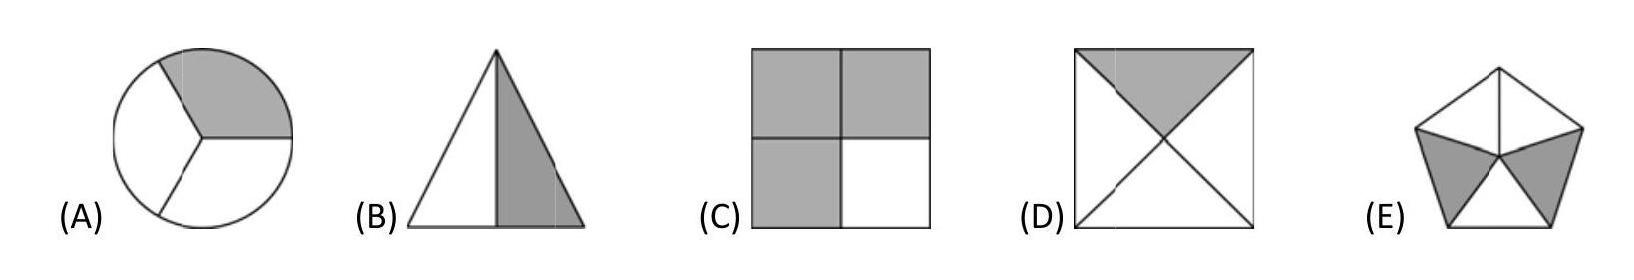Which shape would represent a perfect split if colors were divided horizontally? If we divided the shapes horizontally, shape D would depict a perfect split. The square is divided by diagonal lines into four triangles of equal size, with opposing triangles colored grey. A horizontal division would evenly split these triangles, making half of the square grey and the other half white. 